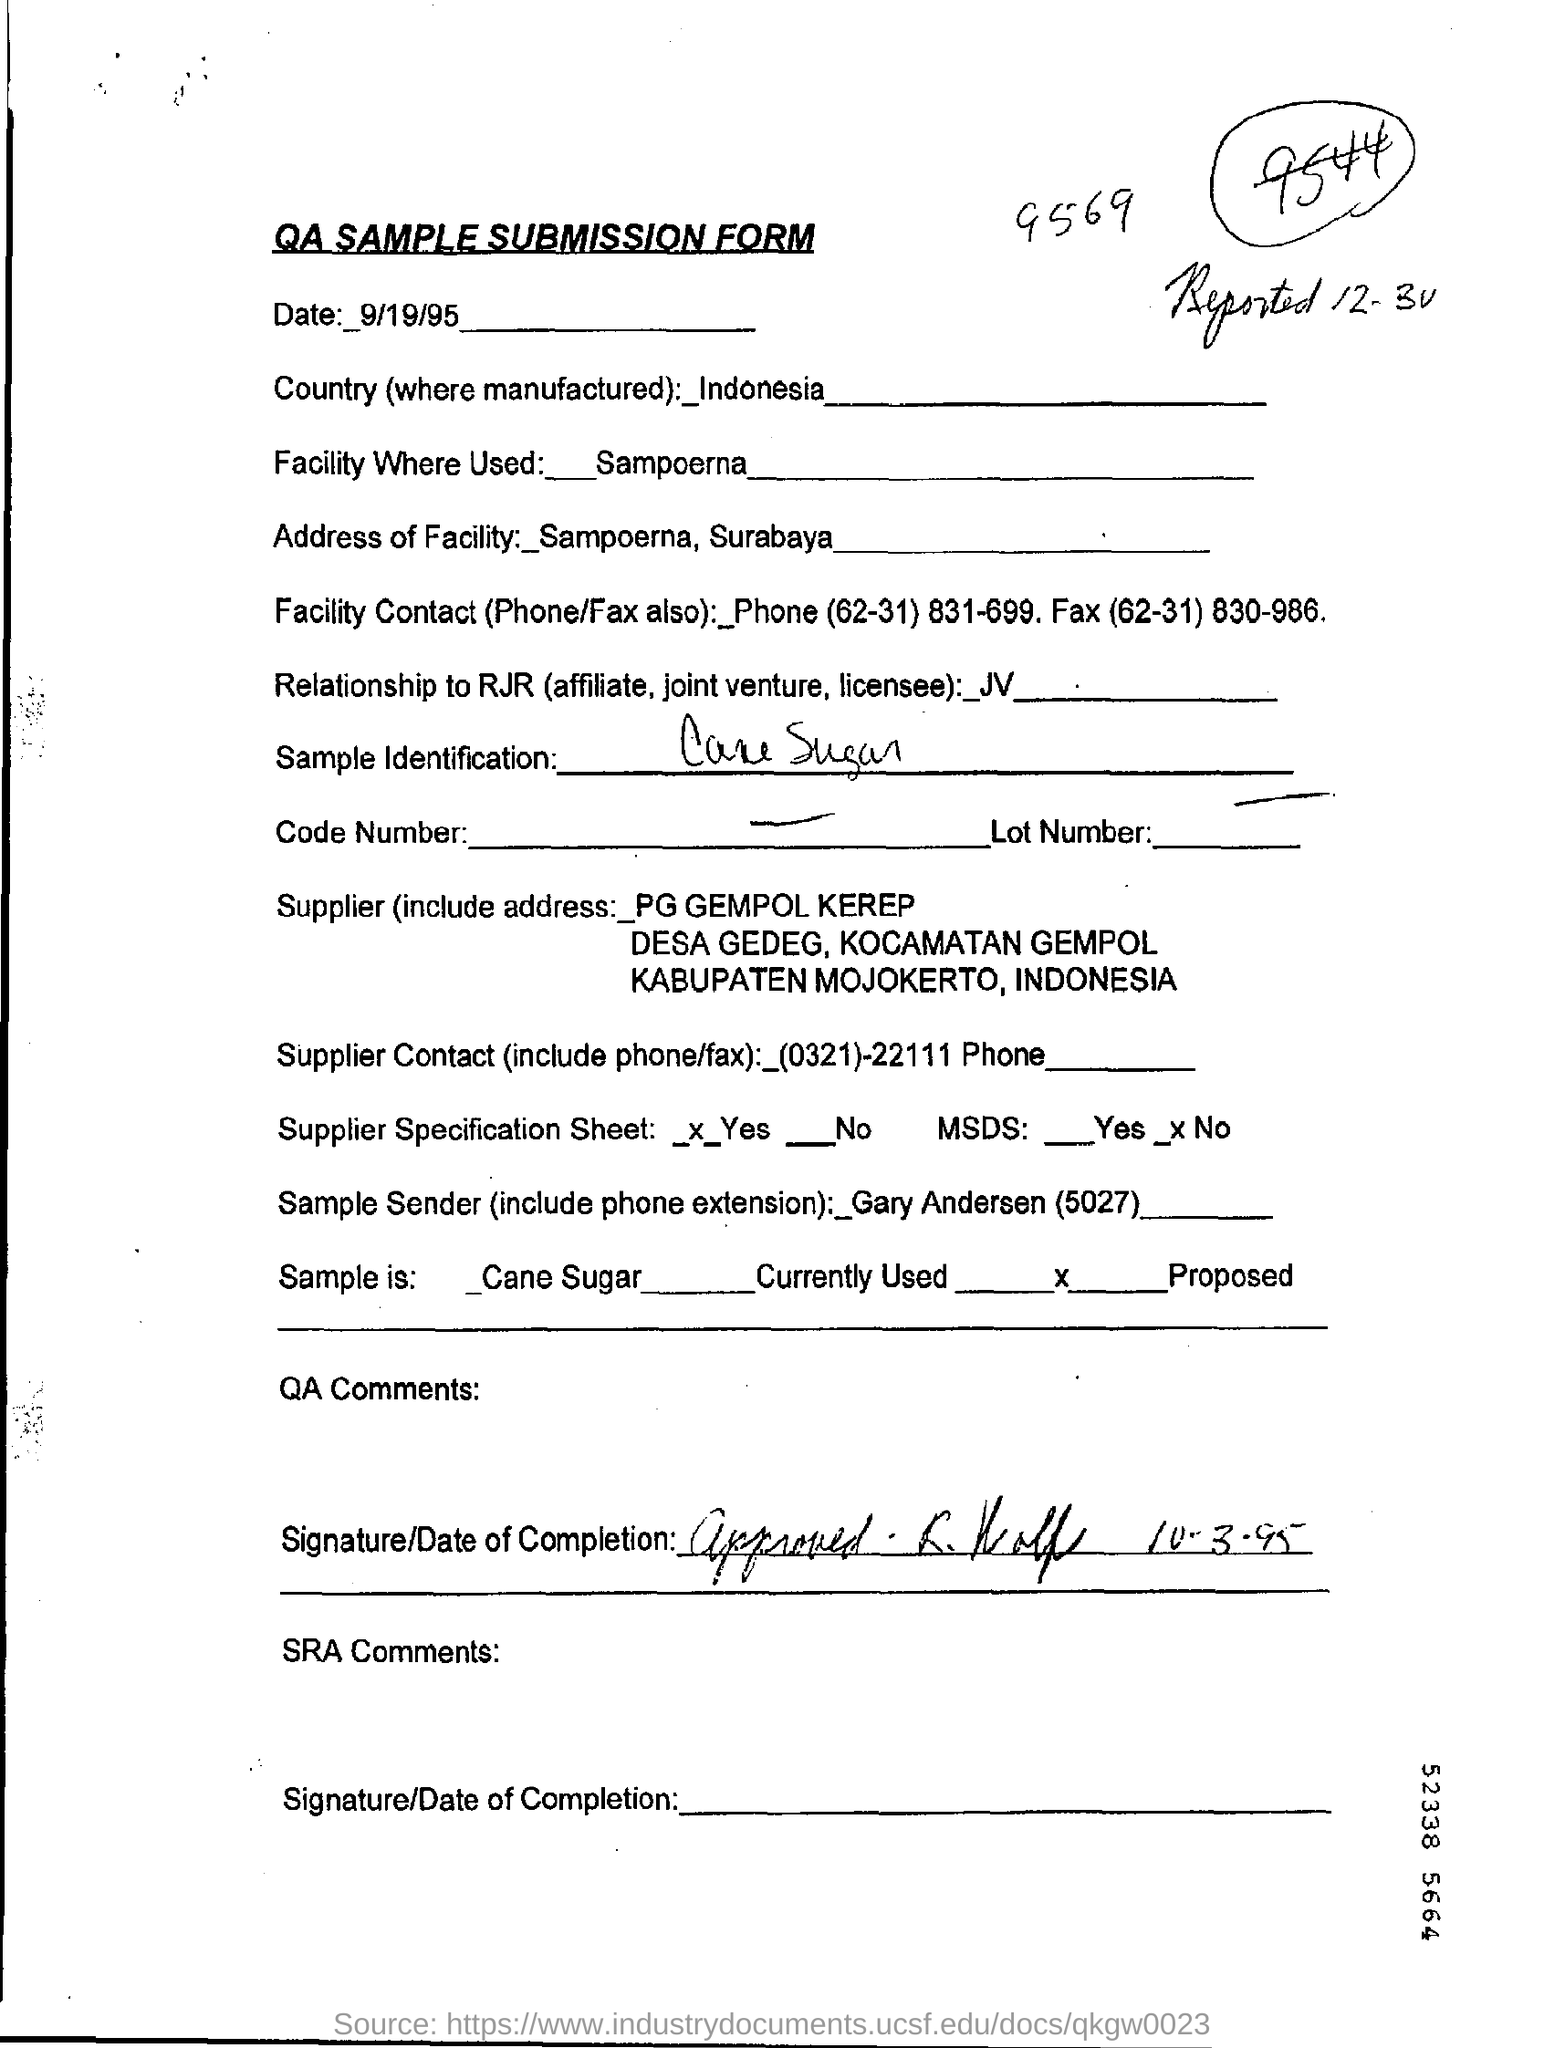Highlight a few significant elements in this photo. The document indicates that the date mentioned at the top of the document is September 19, 1995. The Facility Where Used field mentions Sampoerna. The country name is Indonesia. The title of the document is 'QA Sample Submission Form.' 